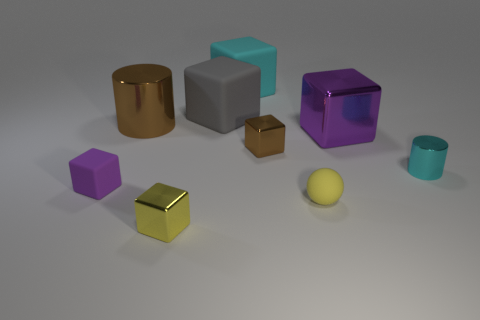Subtract 1 blocks. How many blocks are left? 5 Subtract all gray blocks. How many blocks are left? 5 Subtract all purple blocks. How many blocks are left? 4 Subtract all red blocks. Subtract all cyan cylinders. How many blocks are left? 6 Add 1 large purple cubes. How many objects exist? 10 Subtract all cylinders. How many objects are left? 7 Subtract 0 blue cylinders. How many objects are left? 9 Subtract all small cylinders. Subtract all yellow shiny cubes. How many objects are left? 7 Add 2 cyan matte cubes. How many cyan matte cubes are left? 3 Add 3 cyan balls. How many cyan balls exist? 3 